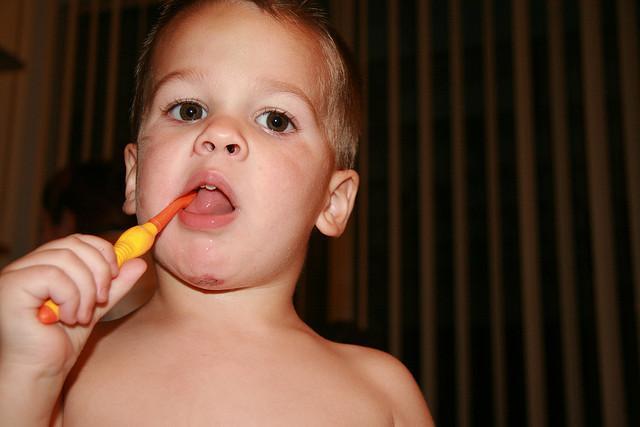How many people are in the picture?
Give a very brief answer. 1. 